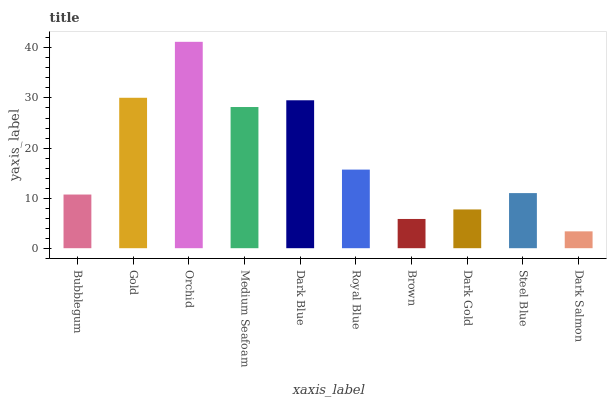Is Dark Salmon the minimum?
Answer yes or no. Yes. Is Orchid the maximum?
Answer yes or no. Yes. Is Gold the minimum?
Answer yes or no. No. Is Gold the maximum?
Answer yes or no. No. Is Gold greater than Bubblegum?
Answer yes or no. Yes. Is Bubblegum less than Gold?
Answer yes or no. Yes. Is Bubblegum greater than Gold?
Answer yes or no. No. Is Gold less than Bubblegum?
Answer yes or no. No. Is Royal Blue the high median?
Answer yes or no. Yes. Is Steel Blue the low median?
Answer yes or no. Yes. Is Brown the high median?
Answer yes or no. No. Is Gold the low median?
Answer yes or no. No. 